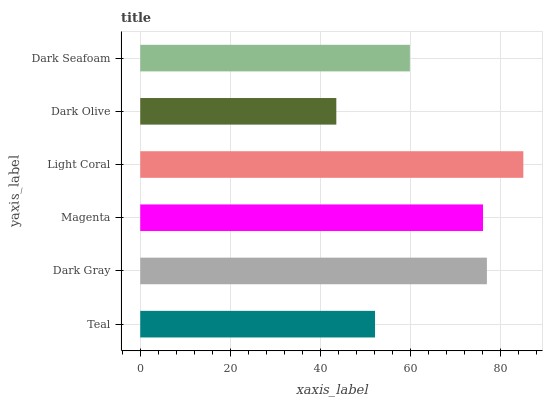Is Dark Olive the minimum?
Answer yes or no. Yes. Is Light Coral the maximum?
Answer yes or no. Yes. Is Dark Gray the minimum?
Answer yes or no. No. Is Dark Gray the maximum?
Answer yes or no. No. Is Dark Gray greater than Teal?
Answer yes or no. Yes. Is Teal less than Dark Gray?
Answer yes or no. Yes. Is Teal greater than Dark Gray?
Answer yes or no. No. Is Dark Gray less than Teal?
Answer yes or no. No. Is Magenta the high median?
Answer yes or no. Yes. Is Dark Seafoam the low median?
Answer yes or no. Yes. Is Dark Olive the high median?
Answer yes or no. No. Is Light Coral the low median?
Answer yes or no. No. 